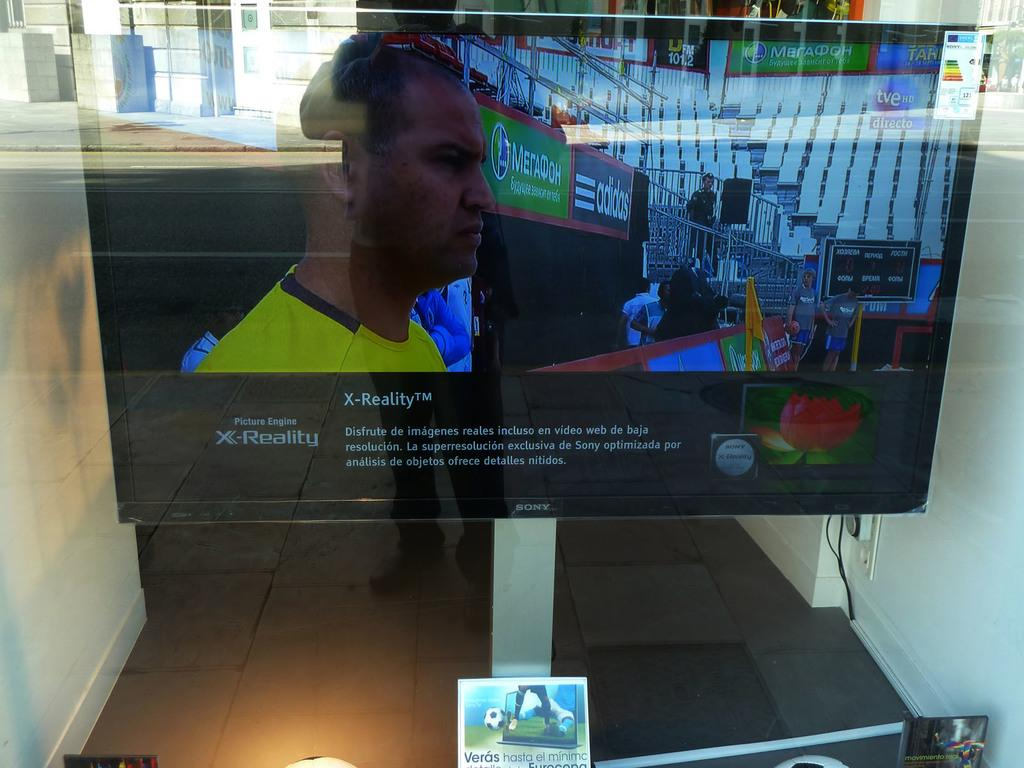Provide a one-sentence caption for the provided image. Flat screen television about x reality on the screen. 